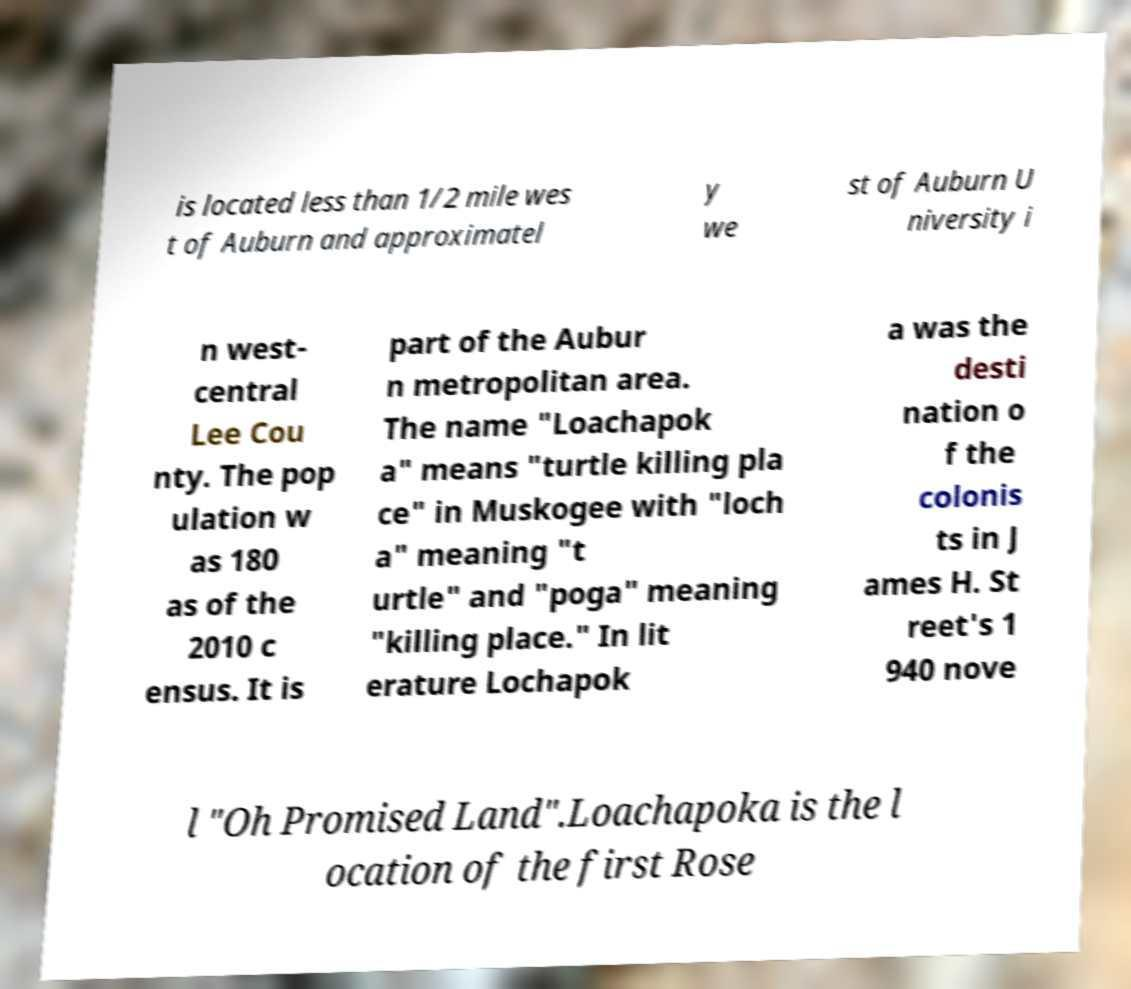I need the written content from this picture converted into text. Can you do that? is located less than 1/2 mile wes t of Auburn and approximatel y we st of Auburn U niversity i n west- central Lee Cou nty. The pop ulation w as 180 as of the 2010 c ensus. It is part of the Aubur n metropolitan area. The name "Loachapok a" means "turtle killing pla ce" in Muskogee with "loch a" meaning "t urtle" and "poga" meaning "killing place." In lit erature Lochapok a was the desti nation o f the colonis ts in J ames H. St reet's 1 940 nove l "Oh Promised Land".Loachapoka is the l ocation of the first Rose 